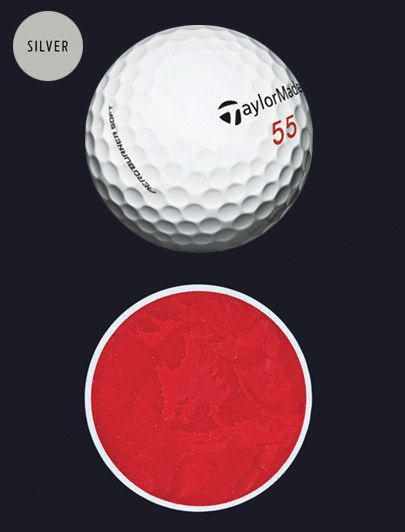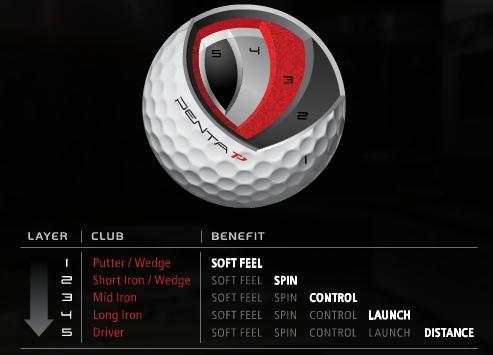The first image is the image on the left, the second image is the image on the right. Analyze the images presented: Is the assertion "An image shows at least four interior layers of a white golf ball." valid? Answer yes or no. Yes. The first image is the image on the left, the second image is the image on the right. Assess this claim about the two images: "Both images show the inside of a golf ball.". Correct or not? Answer yes or no. Yes. 